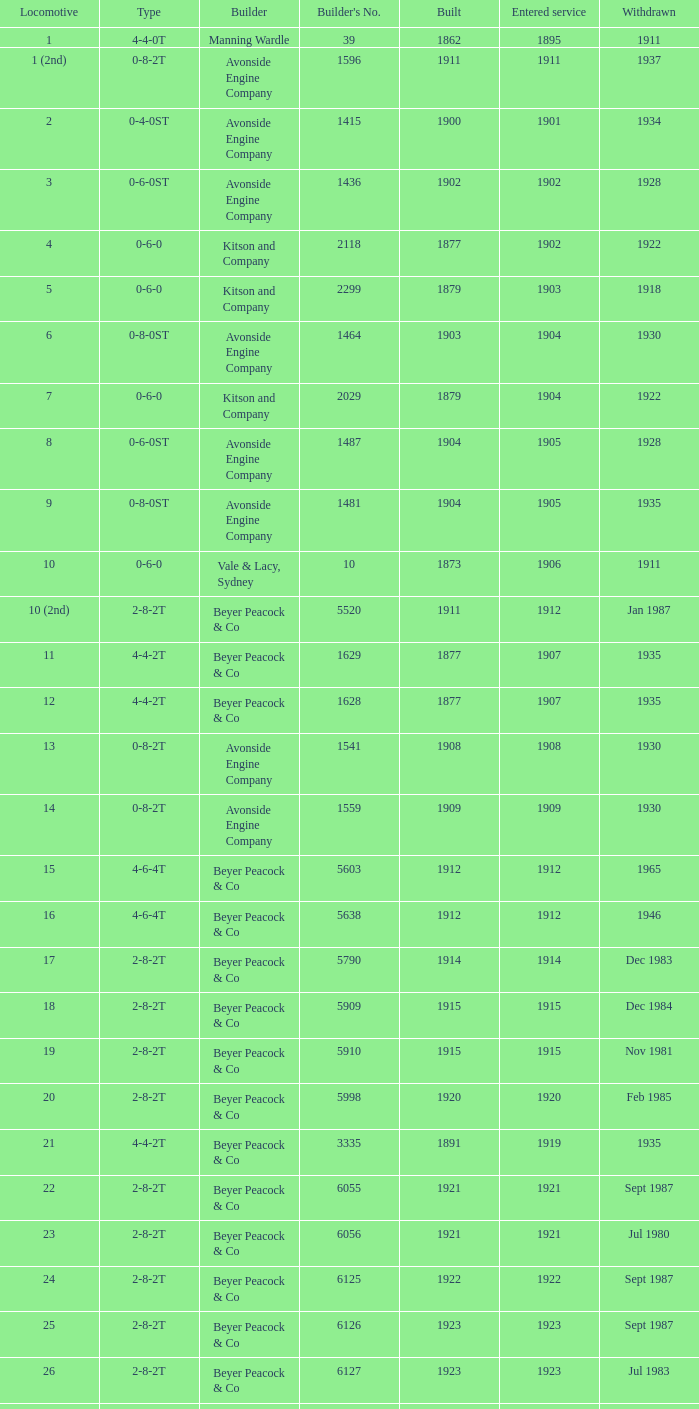How many years entered service when there were 13 locomotives? 1.0. Would you be able to parse every entry in this table? {'header': ['Locomotive', 'Type', 'Builder', "Builder's No.", 'Built', 'Entered service', 'Withdrawn'], 'rows': [['1', '4-4-0T', 'Manning Wardle', '39', '1862', '1895', '1911'], ['1 (2nd)', '0-8-2T', 'Avonside Engine Company', '1596', '1911', '1911', '1937'], ['2', '0-4-0ST', 'Avonside Engine Company', '1415', '1900', '1901', '1934'], ['3', '0-6-0ST', 'Avonside Engine Company', '1436', '1902', '1902', '1928'], ['4', '0-6-0', 'Kitson and Company', '2118', '1877', '1902', '1922'], ['5', '0-6-0', 'Kitson and Company', '2299', '1879', '1903', '1918'], ['6', '0-8-0ST', 'Avonside Engine Company', '1464', '1903', '1904', '1930'], ['7', '0-6-0', 'Kitson and Company', '2029', '1879', '1904', '1922'], ['8', '0-6-0ST', 'Avonside Engine Company', '1487', '1904', '1905', '1928'], ['9', '0-8-0ST', 'Avonside Engine Company', '1481', '1904', '1905', '1935'], ['10', '0-6-0', 'Vale & Lacy, Sydney', '10', '1873', '1906', '1911'], ['10 (2nd)', '2-8-2T', 'Beyer Peacock & Co', '5520', '1911', '1912', 'Jan 1987'], ['11', '4-4-2T', 'Beyer Peacock & Co', '1629', '1877', '1907', '1935'], ['12', '4-4-2T', 'Beyer Peacock & Co', '1628', '1877', '1907', '1935'], ['13', '0-8-2T', 'Avonside Engine Company', '1541', '1908', '1908', '1930'], ['14', '0-8-2T', 'Avonside Engine Company', '1559', '1909', '1909', '1930'], ['15', '4-6-4T', 'Beyer Peacock & Co', '5603', '1912', '1912', '1965'], ['16', '4-6-4T', 'Beyer Peacock & Co', '5638', '1912', '1912', '1946'], ['17', '2-8-2T', 'Beyer Peacock & Co', '5790', '1914', '1914', 'Dec 1983'], ['18', '2-8-2T', 'Beyer Peacock & Co', '5909', '1915', '1915', 'Dec 1984'], ['19', '2-8-2T', 'Beyer Peacock & Co', '5910', '1915', '1915', 'Nov 1981'], ['20', '2-8-2T', 'Beyer Peacock & Co', '5998', '1920', '1920', 'Feb 1985'], ['21', '4-4-2T', 'Beyer Peacock & Co', '3335', '1891', '1919', '1935'], ['22', '2-8-2T', 'Beyer Peacock & Co', '6055', '1921', '1921', 'Sept 1987'], ['23', '2-8-2T', 'Beyer Peacock & Co', '6056', '1921', '1921', 'Jul 1980'], ['24', '2-8-2T', 'Beyer Peacock & Co', '6125', '1922', '1922', 'Sept 1987'], ['25', '2-8-2T', 'Beyer Peacock & Co', '6126', '1923', '1923', 'Sept 1987'], ['26', '2-8-2T', 'Beyer Peacock & Co', '6127', '1923', '1923', 'Jul 1983'], ['27', '2-8-2T', 'Beyer Peacock & Co', '6137', '1923', '1923', 'Mar 1987'], ['28', '2-8-2T', 'Beyer Peacock & Co', '6138', '1923', '1923', 'Dec 1983'], ['29', '4-6-4T', 'Beyer Peacock & Co', '6139', '1923', '1923', '1965'], ['30', '2-8-2T', 'Beyer Peacock & Co', '6294', '1926', '1926', 'Sept 1987'], ['31', '2-8-2T', 'Beyer Peacock & Co', '5295', '1926', '1926', 'Jun 1984']]} 